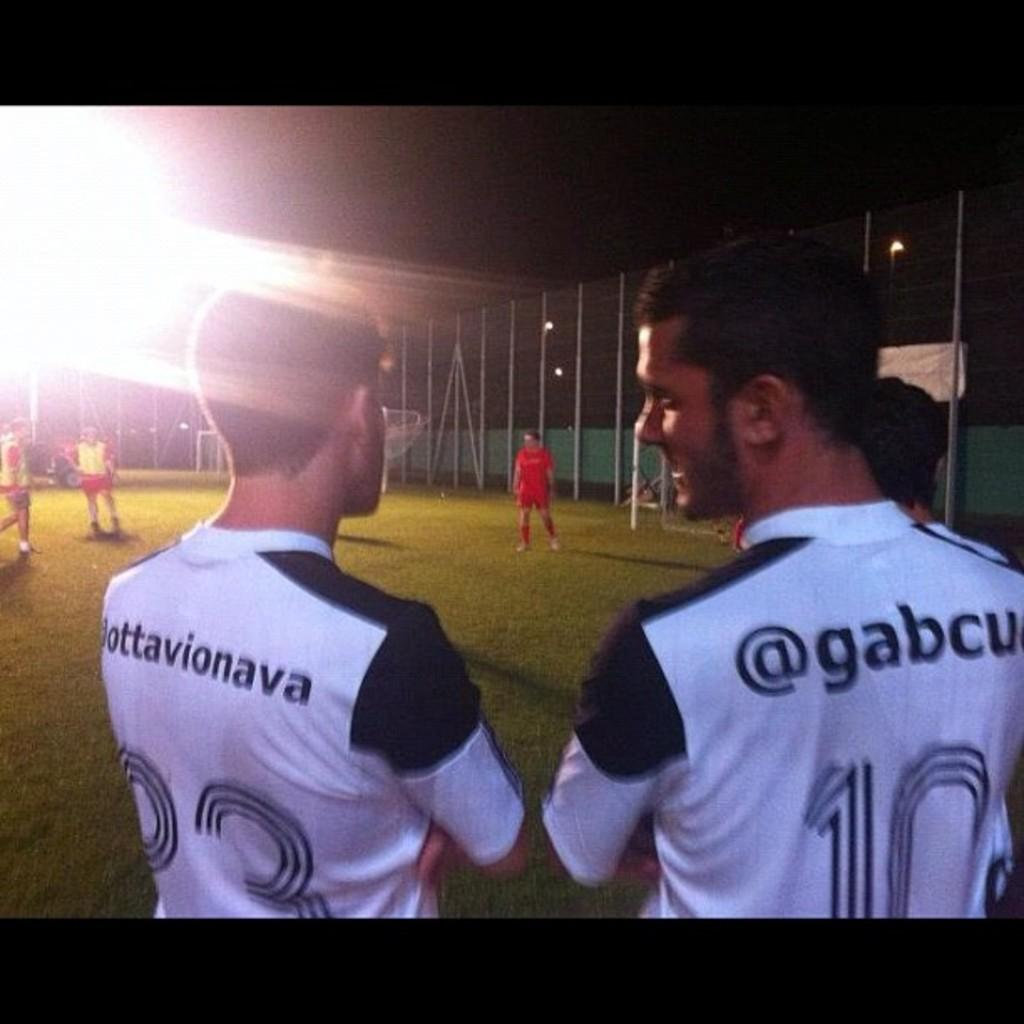Provide a one-sentence caption for the provided image. two men stand next to eachother wearing uniform numbers 33 and 10. 